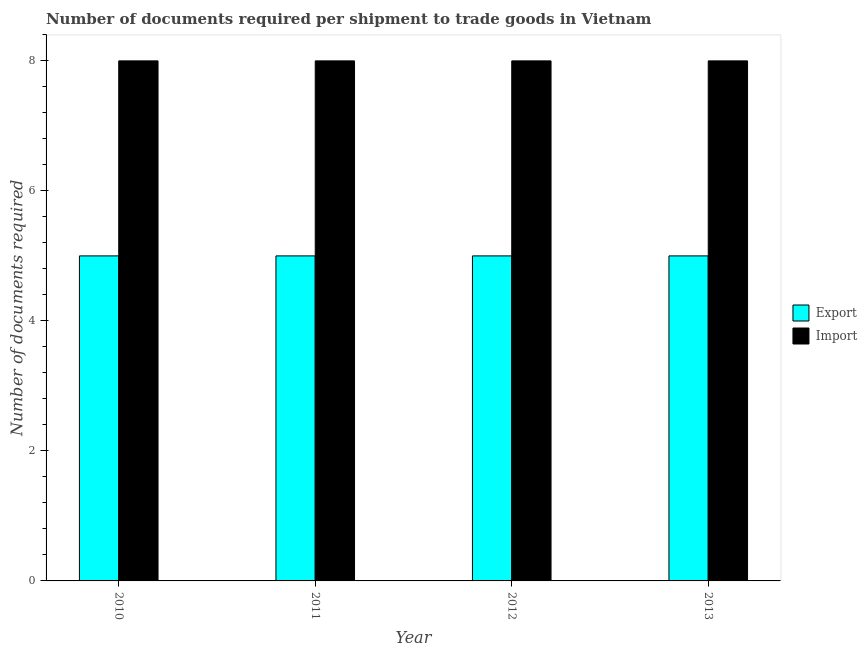How many different coloured bars are there?
Your answer should be compact. 2. Are the number of bars per tick equal to the number of legend labels?
Provide a short and direct response. Yes. Are the number of bars on each tick of the X-axis equal?
Offer a very short reply. Yes. How many bars are there on the 1st tick from the left?
Your answer should be very brief. 2. How many bars are there on the 3rd tick from the right?
Your answer should be compact. 2. What is the label of the 1st group of bars from the left?
Give a very brief answer. 2010. In how many cases, is the number of bars for a given year not equal to the number of legend labels?
Make the answer very short. 0. What is the number of documents required to import goods in 2010?
Provide a succinct answer. 8. Across all years, what is the maximum number of documents required to export goods?
Keep it short and to the point. 5. Across all years, what is the minimum number of documents required to import goods?
Your response must be concise. 8. In which year was the number of documents required to export goods minimum?
Your answer should be compact. 2010. What is the total number of documents required to import goods in the graph?
Offer a terse response. 32. What is the difference between the number of documents required to import goods in 2010 and that in 2011?
Your response must be concise. 0. What is the difference between the number of documents required to export goods in 2011 and the number of documents required to import goods in 2010?
Give a very brief answer. 0. In the year 2013, what is the difference between the number of documents required to import goods and number of documents required to export goods?
Your response must be concise. 0. What is the ratio of the number of documents required to import goods in 2011 to that in 2012?
Give a very brief answer. 1. Is the number of documents required to import goods in 2010 less than that in 2012?
Ensure brevity in your answer.  No. Is the difference between the number of documents required to import goods in 2010 and 2013 greater than the difference between the number of documents required to export goods in 2010 and 2013?
Offer a very short reply. No. What is the difference between the highest and the second highest number of documents required to import goods?
Your response must be concise. 0. In how many years, is the number of documents required to import goods greater than the average number of documents required to import goods taken over all years?
Provide a short and direct response. 0. What does the 1st bar from the left in 2011 represents?
Your answer should be compact. Export. What does the 1st bar from the right in 2012 represents?
Your answer should be very brief. Import. Are all the bars in the graph horizontal?
Ensure brevity in your answer.  No. How many years are there in the graph?
Your response must be concise. 4. What is the difference between two consecutive major ticks on the Y-axis?
Offer a very short reply. 2. Does the graph contain any zero values?
Offer a terse response. No. What is the title of the graph?
Offer a very short reply. Number of documents required per shipment to trade goods in Vietnam. Does "GDP" appear as one of the legend labels in the graph?
Your response must be concise. No. What is the label or title of the Y-axis?
Offer a terse response. Number of documents required. What is the Number of documents required of Export in 2010?
Offer a very short reply. 5. What is the Number of documents required in Export in 2011?
Give a very brief answer. 5. What is the Number of documents required in Import in 2011?
Your response must be concise. 8. Across all years, what is the maximum Number of documents required in Import?
Make the answer very short. 8. Across all years, what is the minimum Number of documents required in Export?
Provide a short and direct response. 5. Across all years, what is the minimum Number of documents required of Import?
Your answer should be compact. 8. What is the total Number of documents required of Import in the graph?
Make the answer very short. 32. What is the difference between the Number of documents required in Import in 2010 and that in 2012?
Provide a short and direct response. 0. What is the difference between the Number of documents required of Export in 2010 and that in 2013?
Your answer should be compact. 0. What is the difference between the Number of documents required of Import in 2010 and that in 2013?
Your answer should be very brief. 0. What is the difference between the Number of documents required of Export in 2011 and that in 2013?
Offer a very short reply. 0. What is the difference between the Number of documents required in Export in 2010 and the Number of documents required in Import in 2011?
Provide a short and direct response. -3. In the year 2010, what is the difference between the Number of documents required in Export and Number of documents required in Import?
Offer a terse response. -3. What is the ratio of the Number of documents required of Export in 2010 to that in 2011?
Your response must be concise. 1. What is the ratio of the Number of documents required in Import in 2010 to that in 2011?
Your answer should be very brief. 1. What is the ratio of the Number of documents required of Export in 2010 to that in 2012?
Your response must be concise. 1. What is the ratio of the Number of documents required in Import in 2010 to that in 2012?
Your response must be concise. 1. What is the ratio of the Number of documents required of Import in 2010 to that in 2013?
Your answer should be compact. 1. What is the ratio of the Number of documents required of Import in 2011 to that in 2012?
Offer a very short reply. 1. What is the ratio of the Number of documents required in Export in 2011 to that in 2013?
Offer a terse response. 1. What is the ratio of the Number of documents required of Import in 2011 to that in 2013?
Give a very brief answer. 1. What is the ratio of the Number of documents required of Import in 2012 to that in 2013?
Ensure brevity in your answer.  1. What is the difference between the highest and the second highest Number of documents required in Export?
Your response must be concise. 0. What is the difference between the highest and the second highest Number of documents required in Import?
Your answer should be compact. 0. What is the difference between the highest and the lowest Number of documents required in Export?
Offer a terse response. 0. What is the difference between the highest and the lowest Number of documents required in Import?
Make the answer very short. 0. 